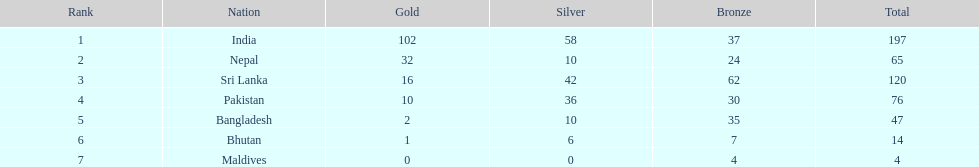Identify a nation mentioned in the chart, excluding india? Nepal. 